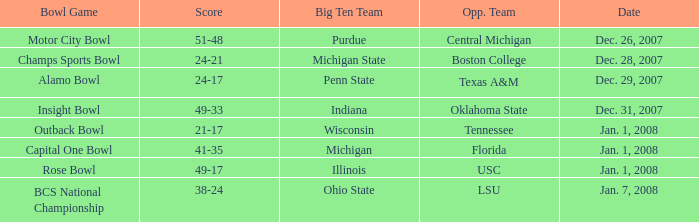Could you parse the entire table? {'header': ['Bowl Game', 'Score', 'Big Ten Team', 'Opp. Team', 'Date'], 'rows': [['Motor City Bowl', '51-48', 'Purdue', 'Central Michigan', 'Dec. 26, 2007'], ['Champs Sports Bowl', '24-21', 'Michigan State', 'Boston College', 'Dec. 28, 2007'], ['Alamo Bowl', '24-17', 'Penn State', 'Texas A&M', 'Dec. 29, 2007'], ['Insight Bowl', '49-33', 'Indiana', 'Oklahoma State', 'Dec. 31, 2007'], ['Outback Bowl', '21-17', 'Wisconsin', 'Tennessee', 'Jan. 1, 2008'], ['Capital One Bowl', '41-35', 'Michigan', 'Florida', 'Jan. 1, 2008'], ['Rose Bowl', '49-17', 'Illinois', 'USC', 'Jan. 1, 2008'], ['BCS National Championship', '38-24', 'Ohio State', 'LSU', 'Jan. 7, 2008']]} What was the score of the Insight Bowl? 49-33. 